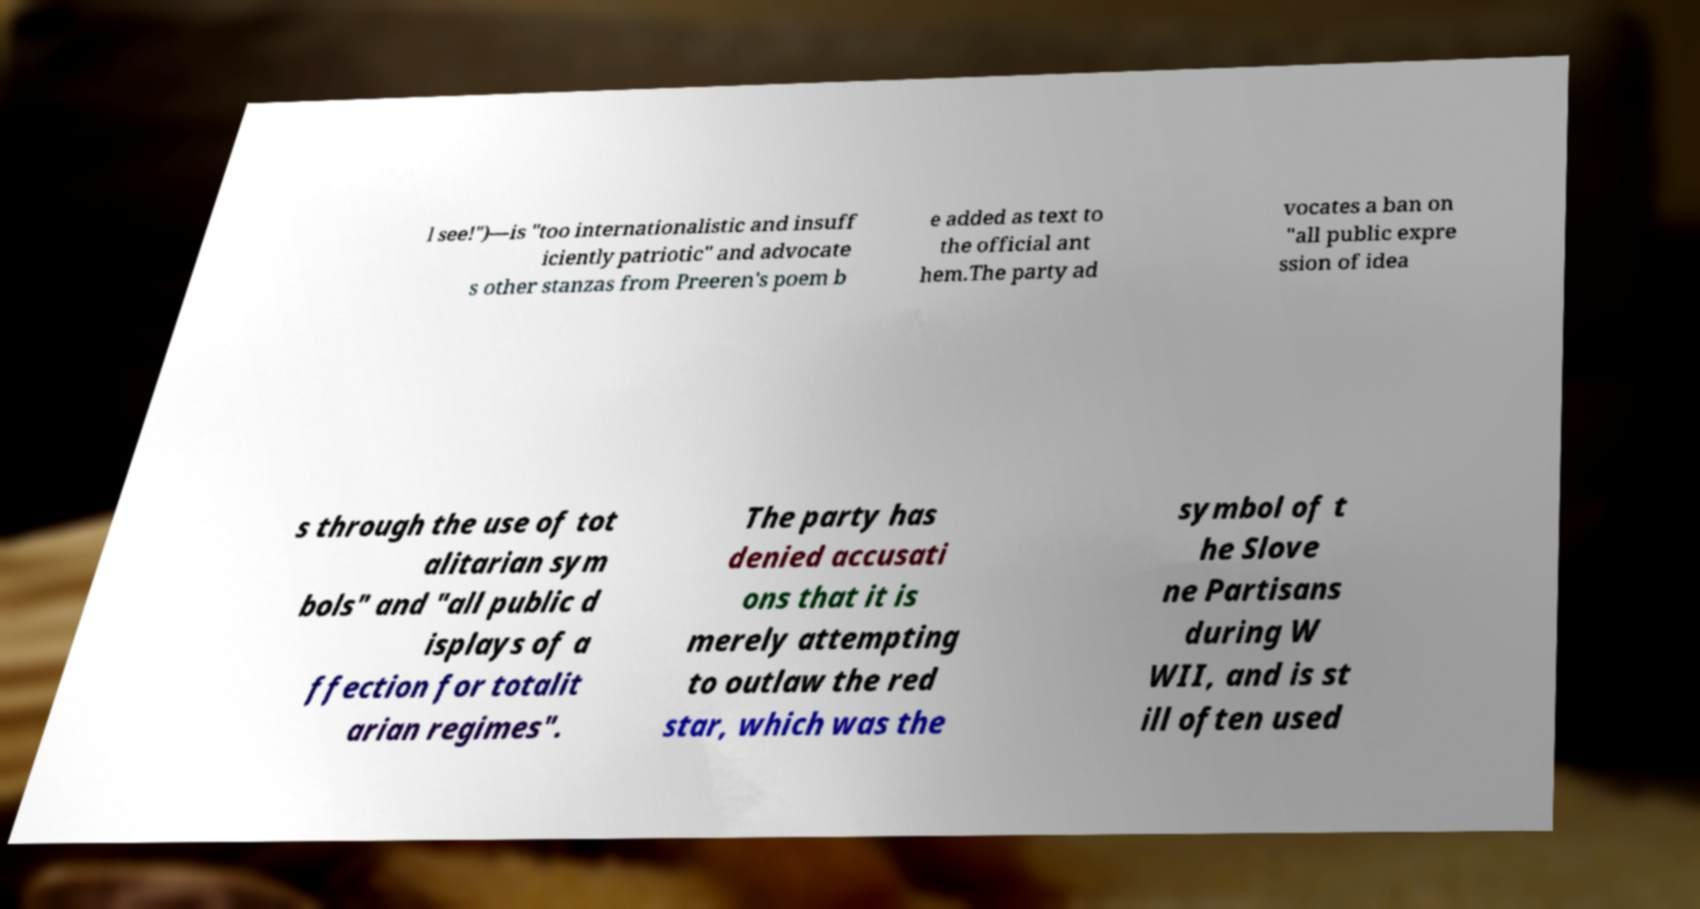Can you read and provide the text displayed in the image?This photo seems to have some interesting text. Can you extract and type it out for me? l see!")—is "too internationalistic and insuff iciently patriotic" and advocate s other stanzas from Preeren's poem b e added as text to the official ant hem.The party ad vocates a ban on "all public expre ssion of idea s through the use of tot alitarian sym bols" and "all public d isplays of a ffection for totalit arian regimes". The party has denied accusati ons that it is merely attempting to outlaw the red star, which was the symbol of t he Slove ne Partisans during W WII, and is st ill often used 